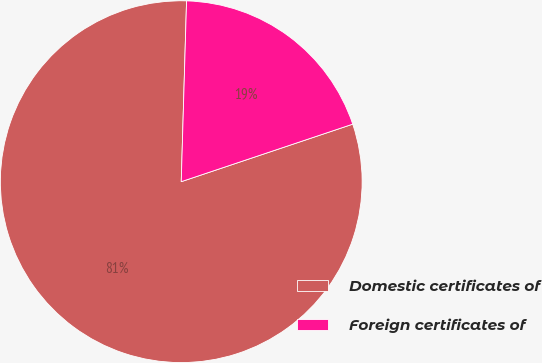Convert chart to OTSL. <chart><loc_0><loc_0><loc_500><loc_500><pie_chart><fcel>Domestic certificates of<fcel>Foreign certificates of<nl><fcel>80.62%<fcel>19.38%<nl></chart> 